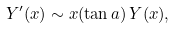<formula> <loc_0><loc_0><loc_500><loc_500>Y ^ { \prime } ( x ) \sim x ( \tan a ) \, Y ( x ) ,</formula> 